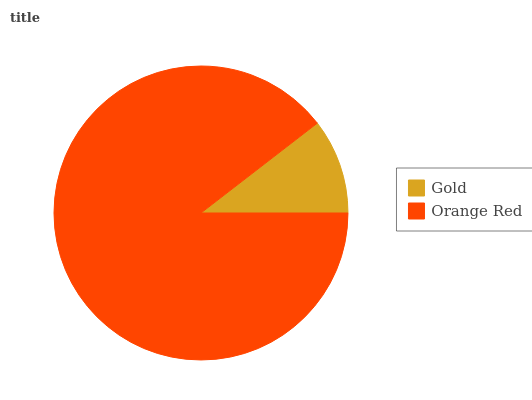Is Gold the minimum?
Answer yes or no. Yes. Is Orange Red the maximum?
Answer yes or no. Yes. Is Orange Red the minimum?
Answer yes or no. No. Is Orange Red greater than Gold?
Answer yes or no. Yes. Is Gold less than Orange Red?
Answer yes or no. Yes. Is Gold greater than Orange Red?
Answer yes or no. No. Is Orange Red less than Gold?
Answer yes or no. No. Is Orange Red the high median?
Answer yes or no. Yes. Is Gold the low median?
Answer yes or no. Yes. Is Gold the high median?
Answer yes or no. No. Is Orange Red the low median?
Answer yes or no. No. 